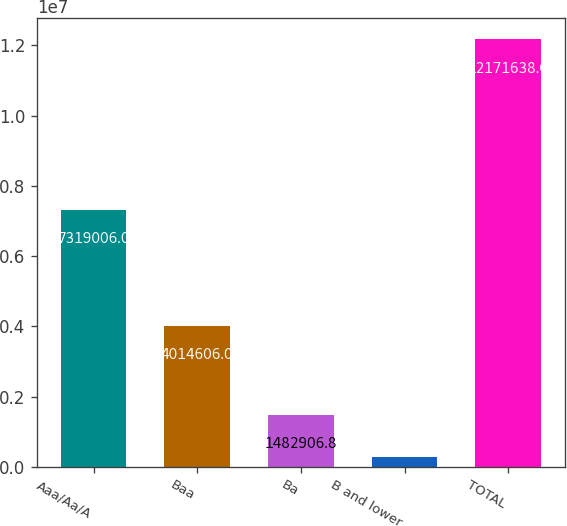Convert chart to OTSL. <chart><loc_0><loc_0><loc_500><loc_500><bar_chart><fcel>Aaa/Aa/A<fcel>Baa<fcel>Ba<fcel>B and lower<fcel>TOTAL<nl><fcel>7.31901e+06<fcel>4.01461e+06<fcel>1.48291e+06<fcel>295270<fcel>1.21716e+07<nl></chart> 